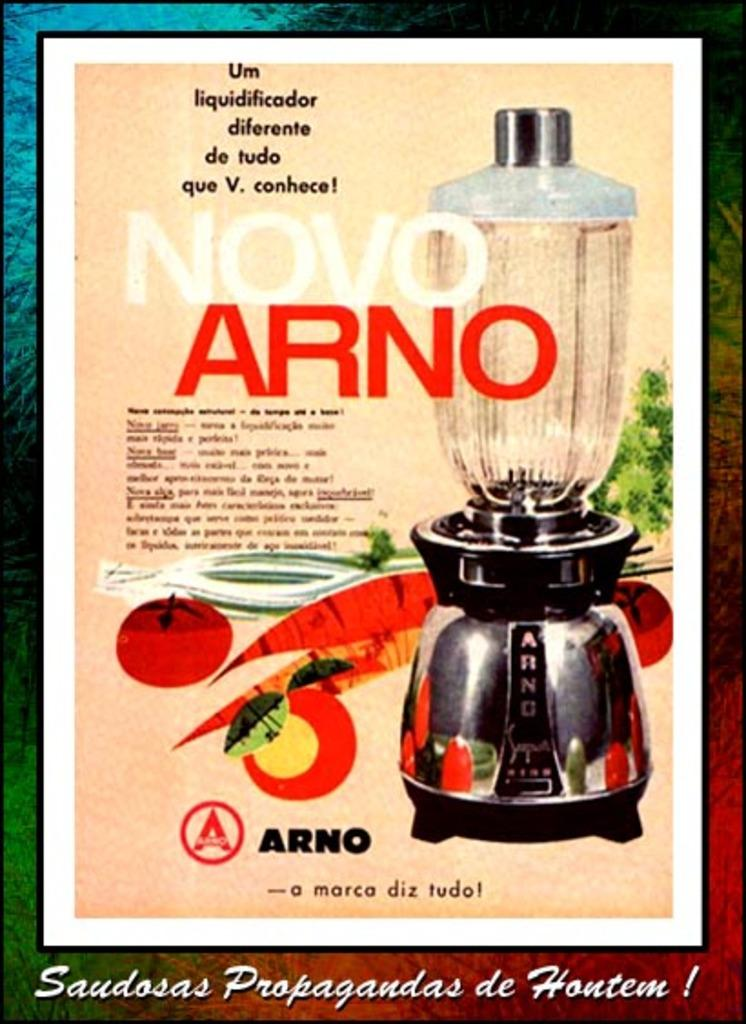<image>
Create a compact narrative representing the image presented. An advertisement for Novo Arno features cartoon drawings of vegetables. 